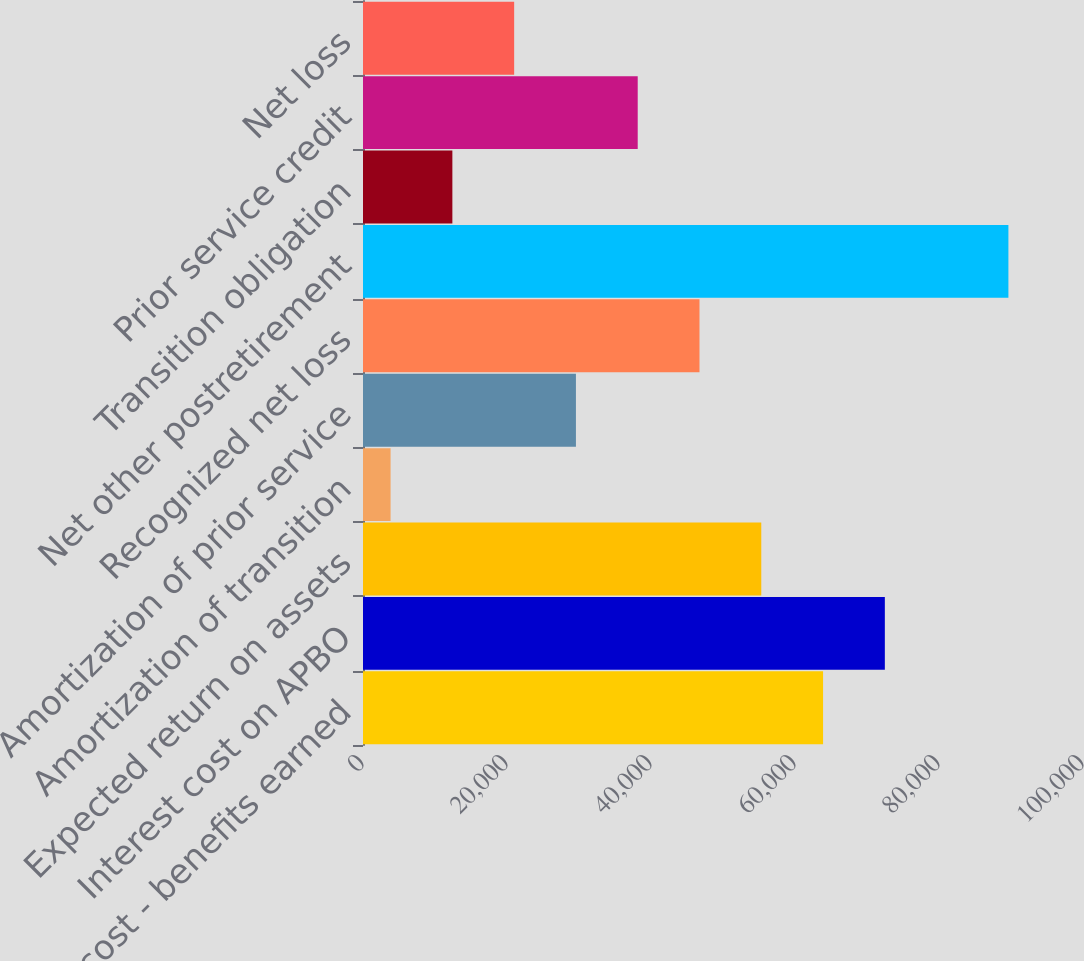Convert chart to OTSL. <chart><loc_0><loc_0><loc_500><loc_500><bar_chart><fcel>Service cost - benefits earned<fcel>Interest cost on APBO<fcel>Expected return on assets<fcel>Amortization of transition<fcel>Amortization of prior service<fcel>Recognized net loss<fcel>Net other postretirement<fcel>Transition obligation<fcel>Prior service credit<fcel>Net loss<nl><fcel>63897.3<fcel>72478.2<fcel>55316.4<fcel>3831<fcel>29573.7<fcel>46735.5<fcel>89640<fcel>12411.9<fcel>38154.6<fcel>20992.8<nl></chart> 